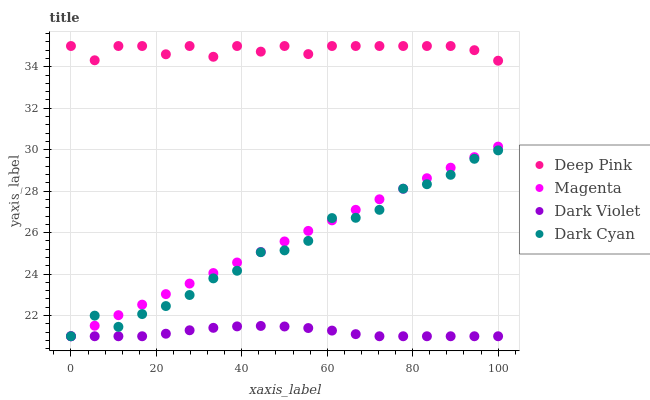Does Dark Violet have the minimum area under the curve?
Answer yes or no. Yes. Does Deep Pink have the maximum area under the curve?
Answer yes or no. Yes. Does Magenta have the minimum area under the curve?
Answer yes or no. No. Does Magenta have the maximum area under the curve?
Answer yes or no. No. Is Magenta the smoothest?
Answer yes or no. Yes. Is Dark Cyan the roughest?
Answer yes or no. Yes. Is Deep Pink the smoothest?
Answer yes or no. No. Is Deep Pink the roughest?
Answer yes or no. No. Does Dark Cyan have the lowest value?
Answer yes or no. Yes. Does Deep Pink have the lowest value?
Answer yes or no. No. Does Deep Pink have the highest value?
Answer yes or no. Yes. Does Magenta have the highest value?
Answer yes or no. No. Is Dark Cyan less than Deep Pink?
Answer yes or no. Yes. Is Deep Pink greater than Dark Violet?
Answer yes or no. Yes. Does Dark Cyan intersect Magenta?
Answer yes or no. Yes. Is Dark Cyan less than Magenta?
Answer yes or no. No. Is Dark Cyan greater than Magenta?
Answer yes or no. No. Does Dark Cyan intersect Deep Pink?
Answer yes or no. No. 